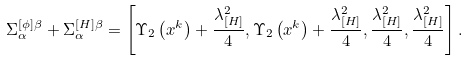<formula> <loc_0><loc_0><loc_500><loc_500>\Sigma _ { \alpha } ^ { [ \phi ] \beta } + \Sigma _ { \alpha } ^ { [ H ] \beta } = \left [ \Upsilon _ { 2 } \left ( x ^ { k } \right ) + \frac { \lambda _ { [ H ] } ^ { 2 } } { 4 } , \Upsilon _ { 2 } \left ( x ^ { k } \right ) + \frac { \lambda _ { [ H ] } ^ { 2 } } { 4 } , \frac { \lambda _ { [ H ] } ^ { 2 } } { 4 } , \frac { \lambda _ { [ H ] } ^ { 2 } } { 4 } \right ] .</formula> 